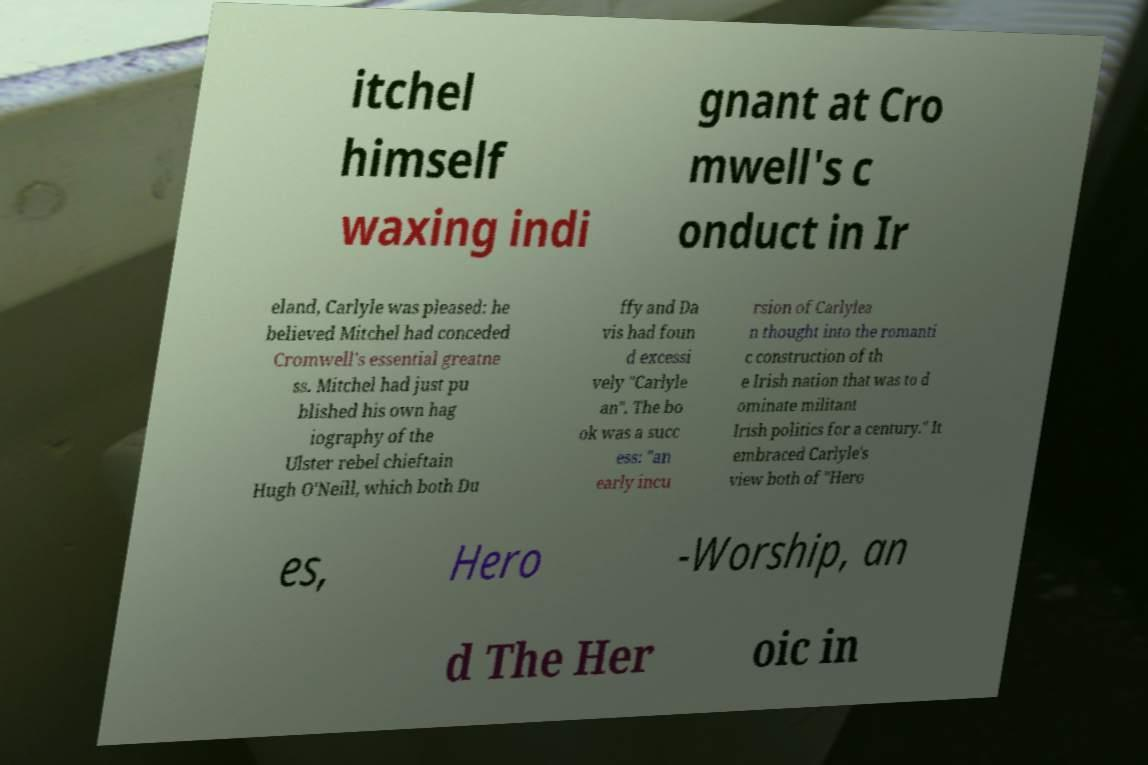Could you assist in decoding the text presented in this image and type it out clearly? itchel himself waxing indi gnant at Cro mwell's c onduct in Ir eland, Carlyle was pleased: he believed Mitchel had conceded Cromwell's essential greatne ss. Mitchel had just pu blished his own hag iography of the Ulster rebel chieftain Hugh O'Neill, which both Du ffy and Da vis had foun d excessi vely "Carlyle an". The bo ok was a succ ess: "an early incu rsion of Carlylea n thought into the romanti c construction of th e Irish nation that was to d ominate militant Irish politics for a century." It embraced Carlyle's view both of "Hero es, Hero -Worship, an d The Her oic in 